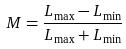<formula> <loc_0><loc_0><loc_500><loc_500>M = \frac { L _ { \max } - L _ { \min } } { L _ { \max } + L _ { \min } }</formula> 